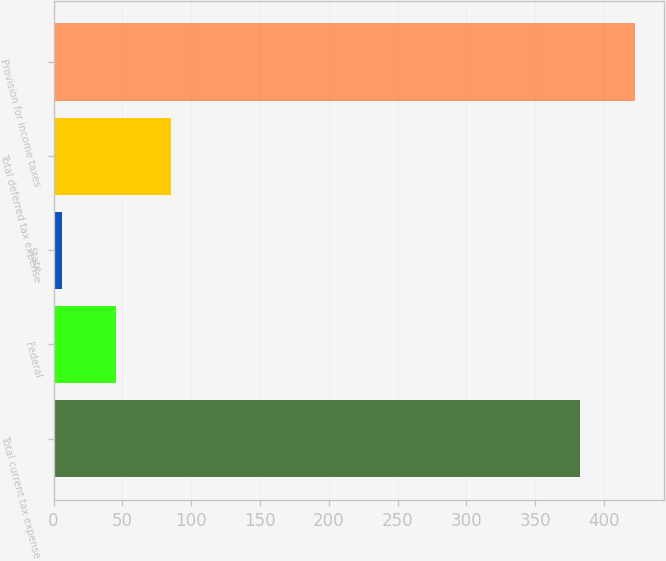Convert chart. <chart><loc_0><loc_0><loc_500><loc_500><bar_chart><fcel>Total current tax expense<fcel>Federal<fcel>State<fcel>Total deferred tax expense<fcel>Provision for income taxes<nl><fcel>383<fcel>45.6<fcel>6<fcel>85.2<fcel>422.6<nl></chart> 